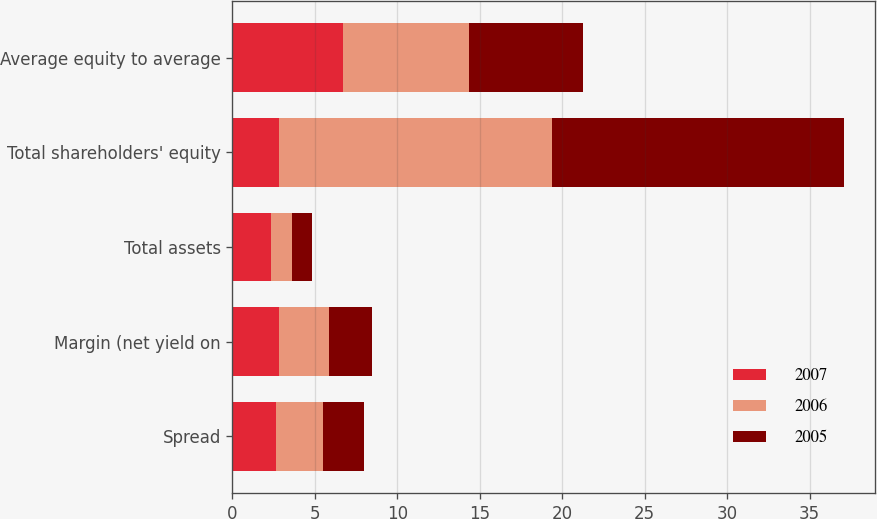Convert chart to OTSL. <chart><loc_0><loc_0><loc_500><loc_500><stacked_bar_chart><ecel><fcel>Spread<fcel>Margin (net yield on<fcel>Total assets<fcel>Total shareholders' equity<fcel>Average equity to average<nl><fcel>2007<fcel>2.63<fcel>2.81<fcel>2.34<fcel>2.83<fcel>6.73<nl><fcel>2006<fcel>2.85<fcel>3.03<fcel>1.26<fcel>16.56<fcel>7.61<nl><fcel>2005<fcel>2.49<fcel>2.62<fcel>1.22<fcel>17.7<fcel>6.9<nl></chart> 